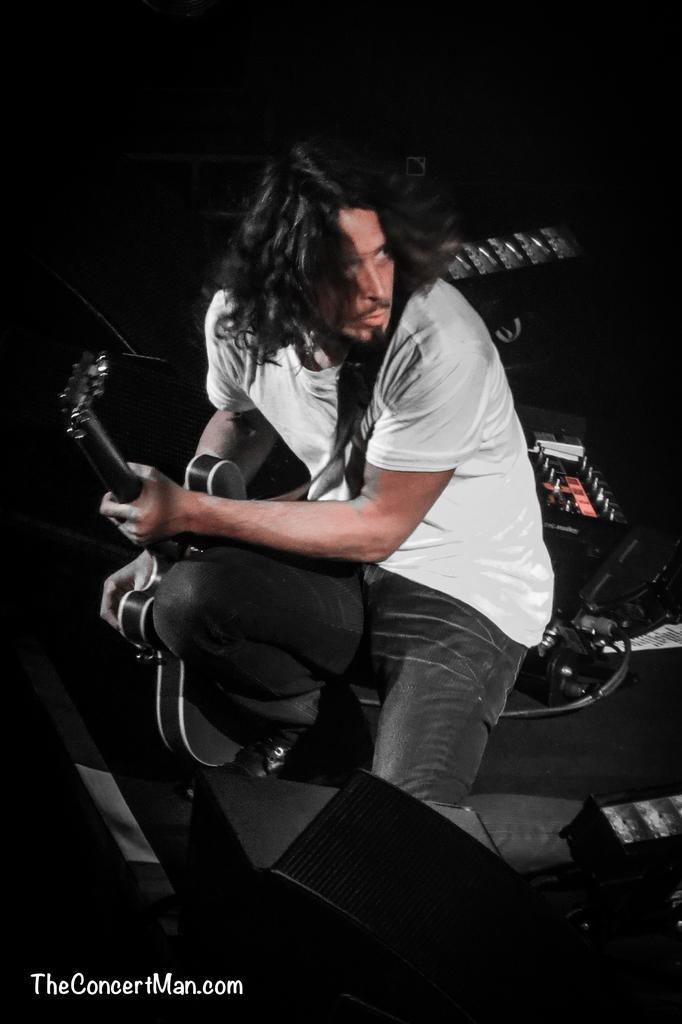How would you summarize this image in a sentence or two? In the image we can see one person sitting and holding guitar. In the background we can see few musical instruments. 